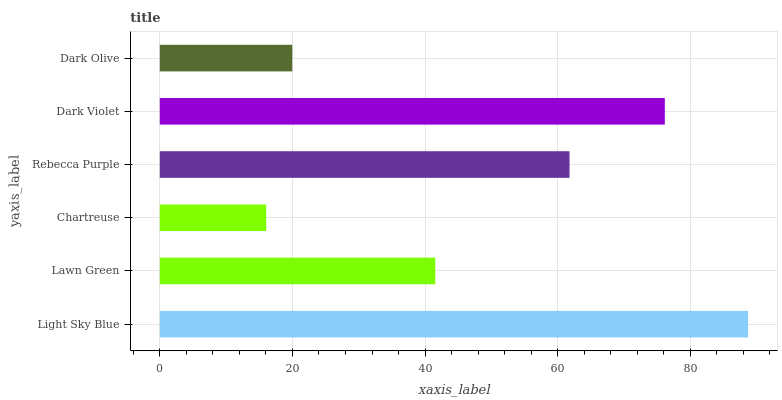Is Chartreuse the minimum?
Answer yes or no. Yes. Is Light Sky Blue the maximum?
Answer yes or no. Yes. Is Lawn Green the minimum?
Answer yes or no. No. Is Lawn Green the maximum?
Answer yes or no. No. Is Light Sky Blue greater than Lawn Green?
Answer yes or no. Yes. Is Lawn Green less than Light Sky Blue?
Answer yes or no. Yes. Is Lawn Green greater than Light Sky Blue?
Answer yes or no. No. Is Light Sky Blue less than Lawn Green?
Answer yes or no. No. Is Rebecca Purple the high median?
Answer yes or no. Yes. Is Lawn Green the low median?
Answer yes or no. Yes. Is Lawn Green the high median?
Answer yes or no. No. Is Dark Violet the low median?
Answer yes or no. No. 